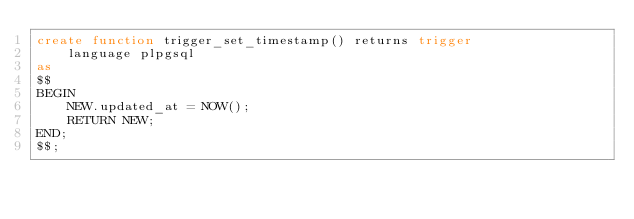Convert code to text. <code><loc_0><loc_0><loc_500><loc_500><_SQL_>create function trigger_set_timestamp() returns trigger
    language plpgsql
as
$$
BEGIN
    NEW.updated_at = NOW();
    RETURN NEW;
END;
$$;</code> 